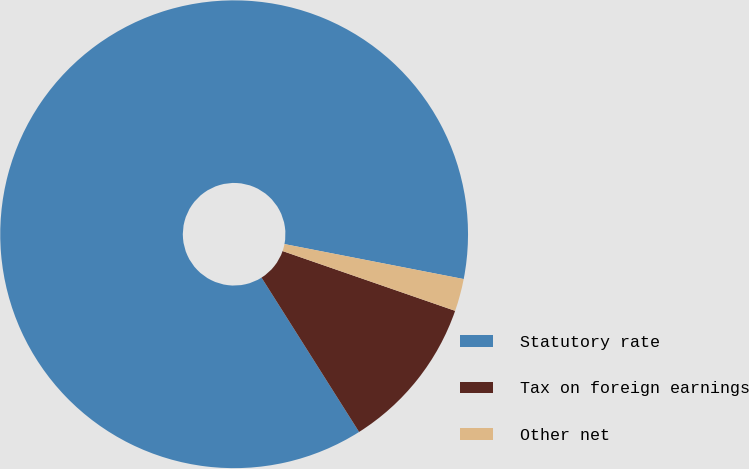Convert chart to OTSL. <chart><loc_0><loc_0><loc_500><loc_500><pie_chart><fcel>Statutory rate<fcel>Tax on foreign earnings<fcel>Other net<nl><fcel>87.04%<fcel>10.72%<fcel>2.24%<nl></chart> 